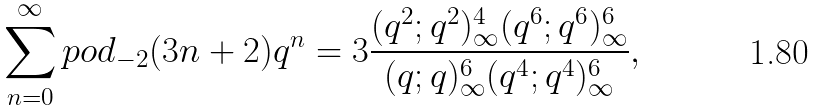<formula> <loc_0><loc_0><loc_500><loc_500>\sum _ { n = 0 } ^ { \infty } p o d _ { - 2 } ( 3 n + 2 ) q ^ { n } = 3 \frac { ( q ^ { 2 } ; q ^ { 2 } ) _ { \infty } ^ { 4 } ( q ^ { 6 } ; q ^ { 6 } ) _ { \infty } ^ { 6 } } { ( q ; q ) _ { \infty } ^ { 6 } ( q ^ { 4 } ; q ^ { 4 } ) _ { \infty } ^ { 6 } } ,</formula> 